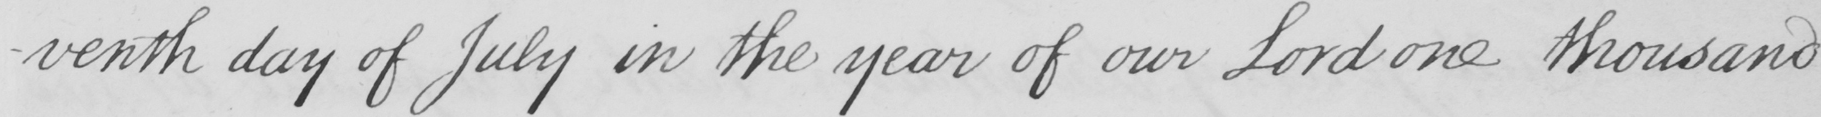What is written in this line of handwriting? -venth day of July in the year of our Lord one thousand 